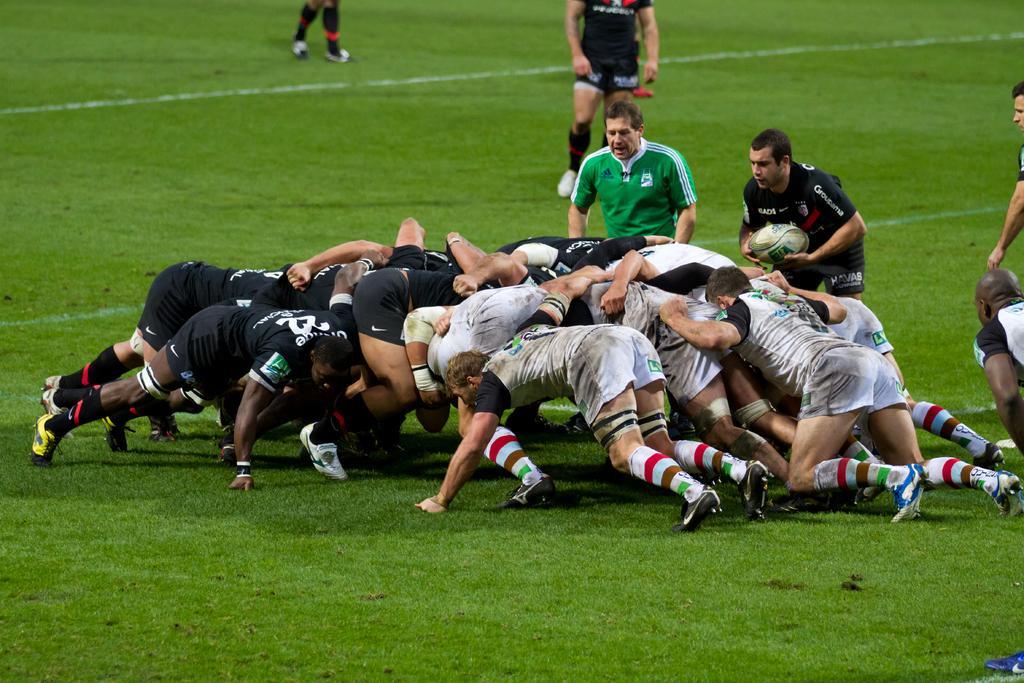Please provide a concise description of this image. In this image, we can see persons wearing clothes and playing rugby. There is a person on the right side of the image holding a ball with his hands. There is a grass on the ground. 